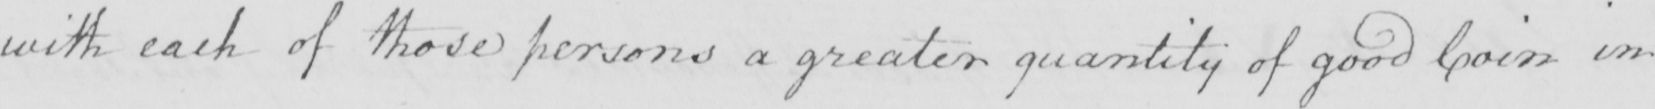Can you tell me what this handwritten text says? with each of those persons a greater quantity of good Coin in 